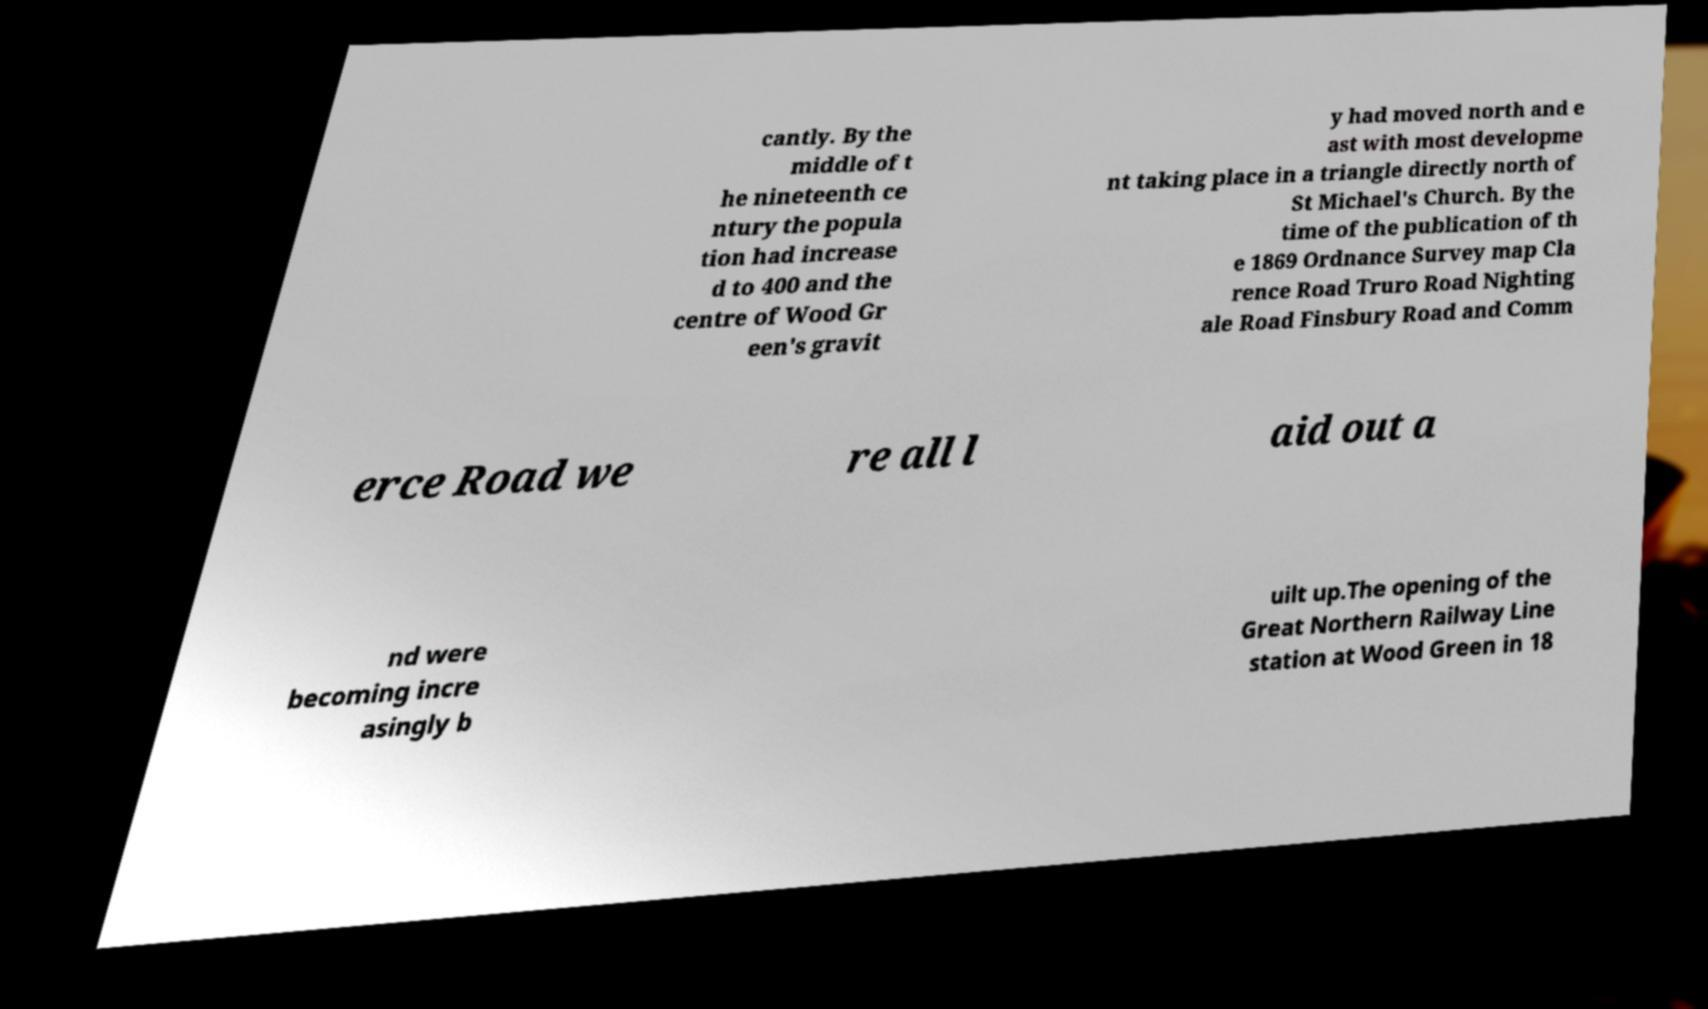Please read and relay the text visible in this image. What does it say? cantly. By the middle of t he nineteenth ce ntury the popula tion had increase d to 400 and the centre of Wood Gr een's gravit y had moved north and e ast with most developme nt taking place in a triangle directly north of St Michael's Church. By the time of the publication of th e 1869 Ordnance Survey map Cla rence Road Truro Road Nighting ale Road Finsbury Road and Comm erce Road we re all l aid out a nd were becoming incre asingly b uilt up.The opening of the Great Northern Railway Line station at Wood Green in 18 